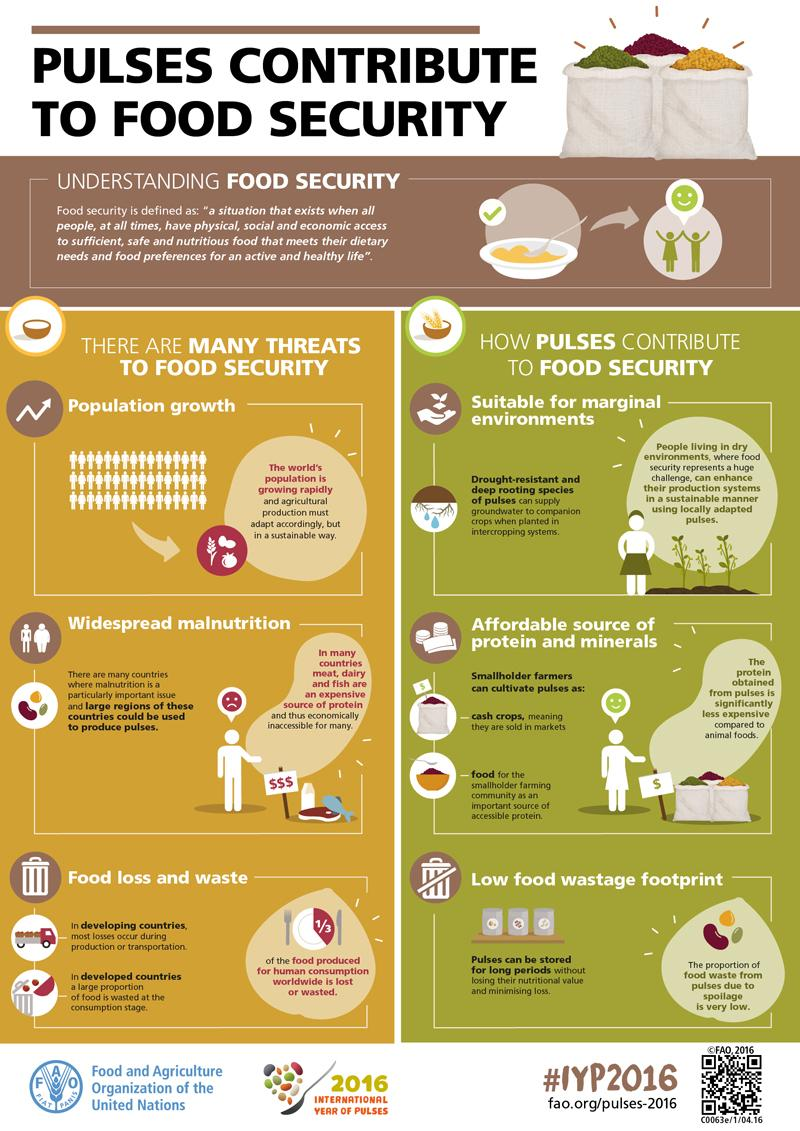Mention a couple of crucial points in this snapshot. Population growth is the first and most significant threat to food security. 